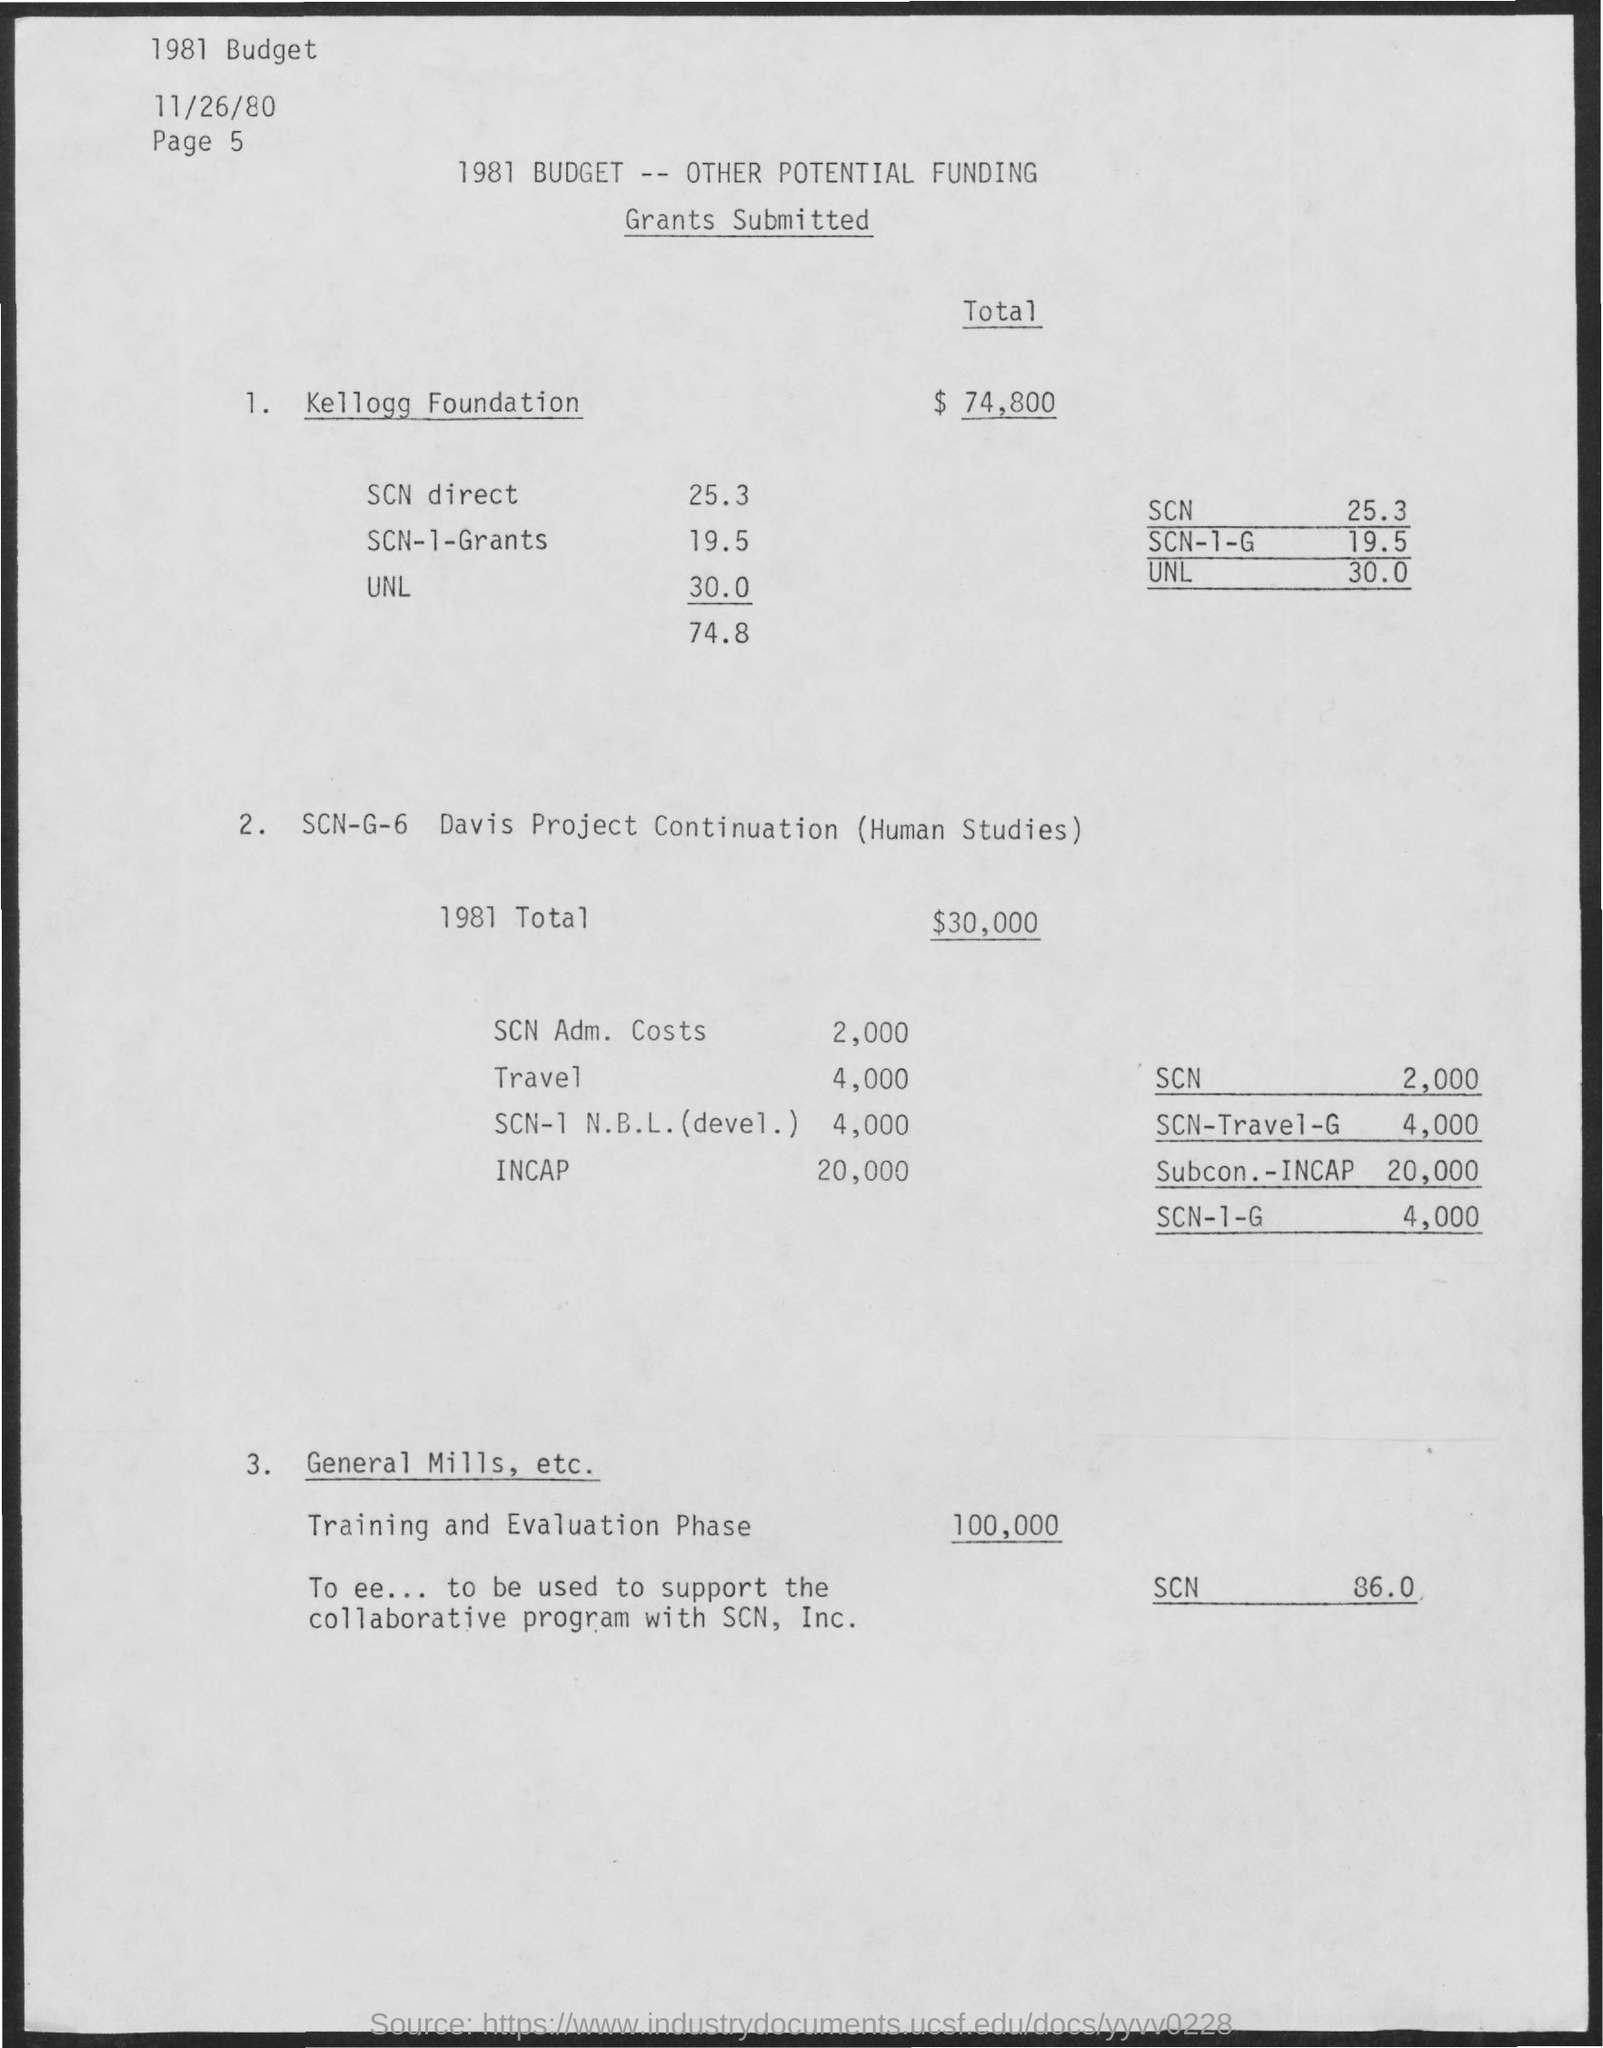Can you explain what the Kellogg Foundation grant is for? The Kellogg Foundation grant, totaling $74,800, appears to be earmarked for several items. It includes direct support for SCN (25.3%), SCN-I-Grants (19.5%), and UNL (30.0%). However, the specific purposes of these funds are not detailed in this document. 